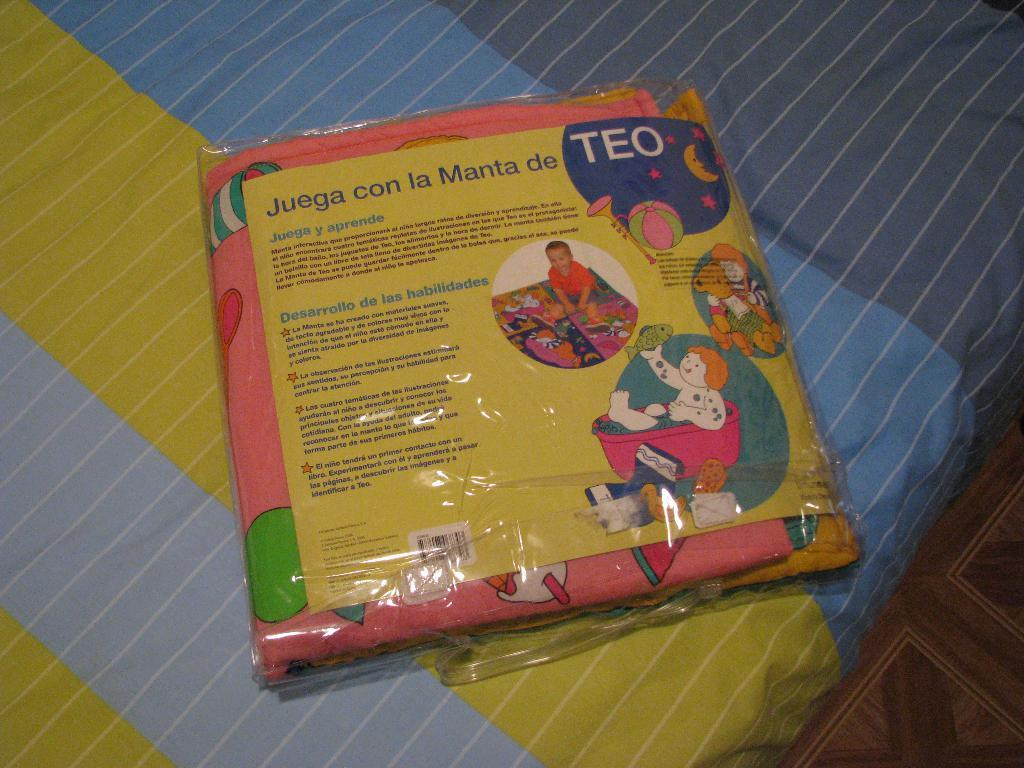What color is the object that is visible in the image? The object in the image is pink. How is the pink object being protected or covered? The pink object is in a cover. Is there any text or information on the pink object? Yes, the pink object has a label on it. Where is the pink object located in the image? The pink object is placed on a bed. What part of the room can be seen in the image? The floor is visible in the image. What type of music is being played by the government in the image? There is no music or government present in the image; it features a pink object in a cover on a bed. 